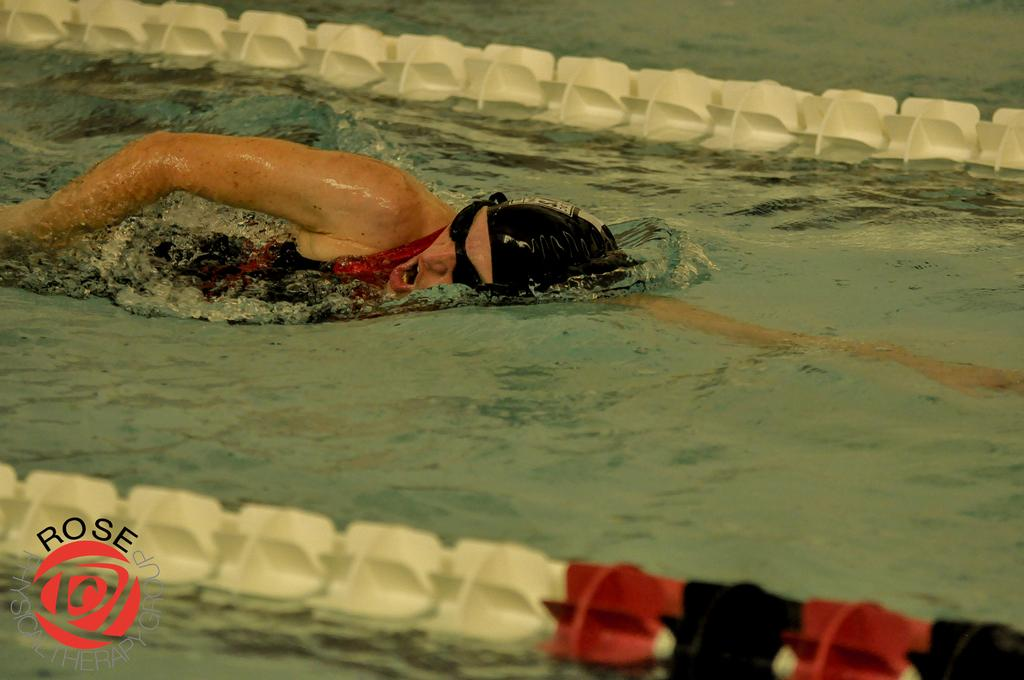What is visible in the image? There is water visible in the image. What is the person in the image doing? A person is swimming in the water. Can you describe any objects in the image? There are two ropes in the image. What type of oatmeal is being served in the image? There is no oatmeal present in the image; it features water and a person swimming. 